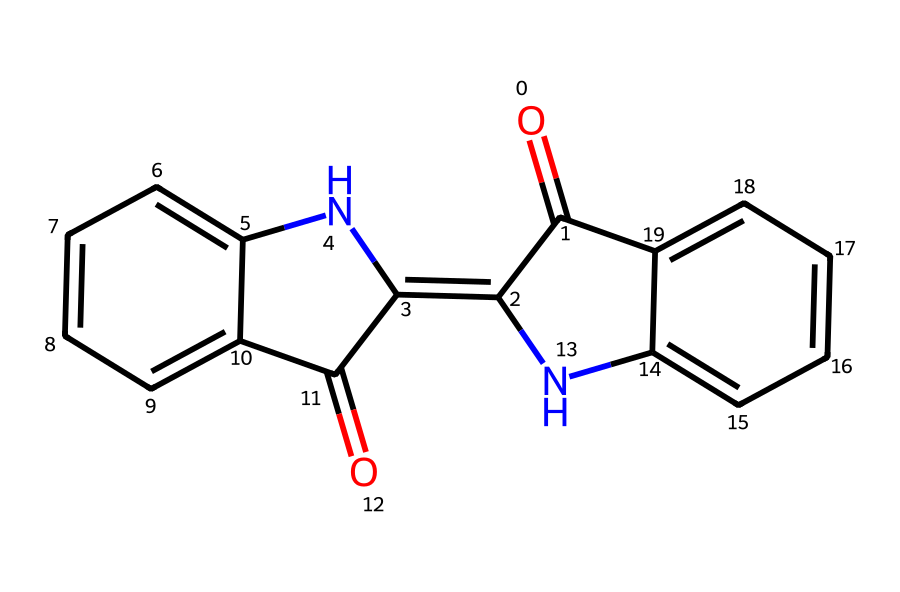What is the molecular formula of this compound? To find the molecular formula, we count the number of each type of atom present in the structure. The structure contains 15 carbon (C) atoms, 10 hydrogen (H) atoms, 4 oxygen (O) atoms, and 2 nitrogen (N) atoms. Thus, the molecular formula can be written as C15H10N2O4.
Answer: C15H10N2O4 How many rings are present in this chemical structure? Upon examining the structure, we can identify that there are three distinct rings: two benzene rings and a pyrrole-containing ring. Hence, the total number of rings in the structure is three.
Answer: three What type of chemical structure does this represent? This chemical contains multiple aromatic rings and nitrogen atoms, indicating that it resembles an anthraquinone derivative or a type of dye with a polycyclic aromatic structure. Thus, it can be classified as an organic dye.
Answer: organic dye Which elements are involved in this molecular structure? By analyzing the provided SMILES representation, we identify the following elements: carbon (C), hydrogen (H), nitrogen (N), and oxygen (O). Together, these elements form the entire molecular structure.
Answer: carbon, hydrogen, nitrogen, oxygen How many double bonds are there in this compound? By closely observing the structure, we can locate the double bonds present in the connections between carbon atoms and also between carbon and nitrogen. Specifically, there are six double bonds within this structure.
Answer: six What is the primary functional group present in the chemical? The compound contains carbonyl functional groups, indicated by the presence of C=O moieties. This is evident in the structure, suggesting that ketones and/or amides are likely present.
Answer: carbonyl What is the significance of nitrogen atoms in this structure? The presence of nitrogen atoms typically indicates that the compound may have biological activity, as nitrogen-containing compounds like this can serve as bases in dyes and pigments. Their role often involves chromophore systems responsible for color characteristics.
Answer: biological activity 